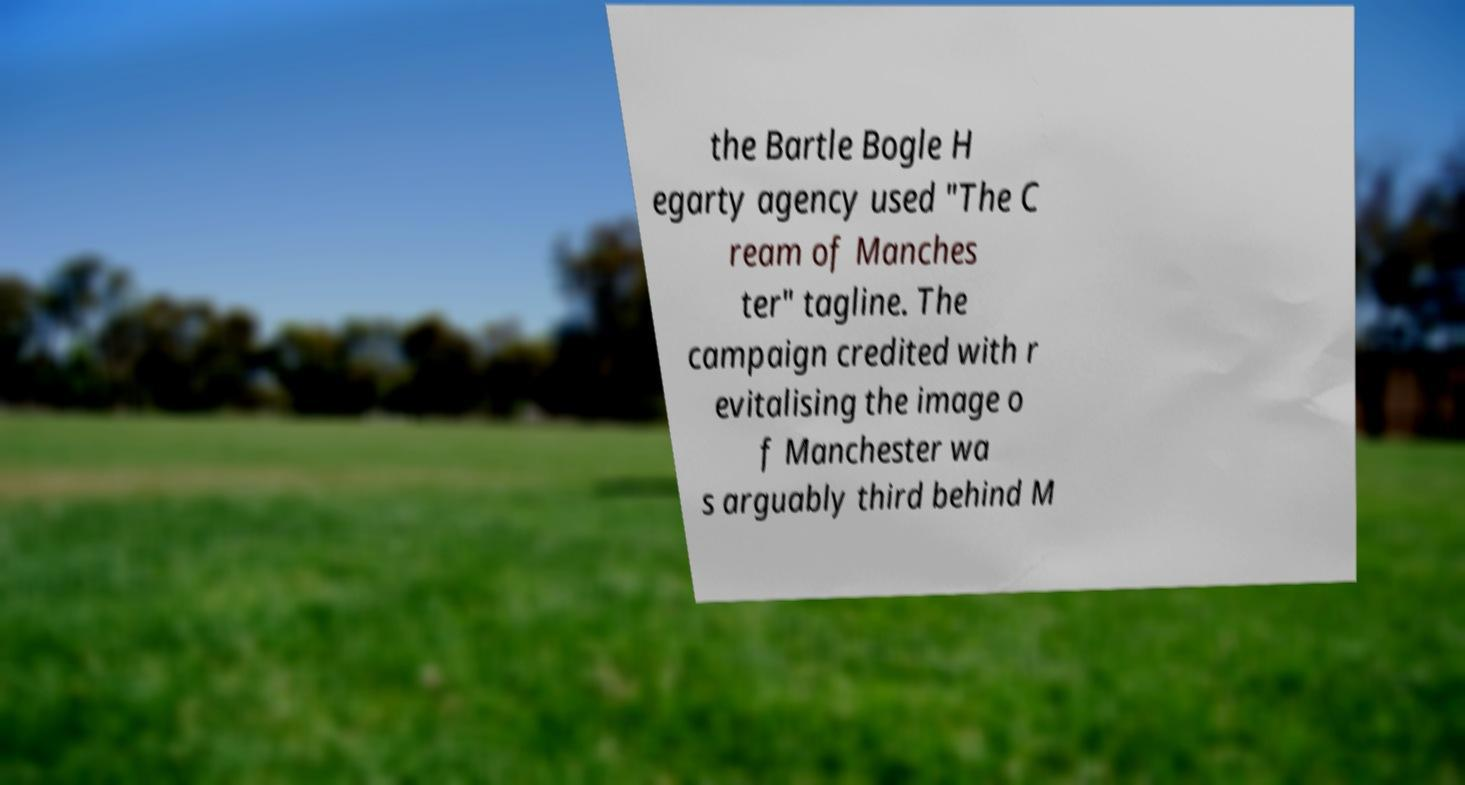Could you extract and type out the text from this image? the Bartle Bogle H egarty agency used "The C ream of Manches ter" tagline. The campaign credited with r evitalising the image o f Manchester wa s arguably third behind M 